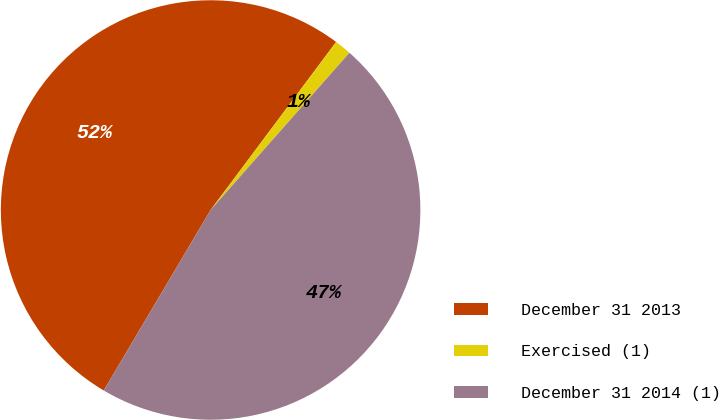Convert chart to OTSL. <chart><loc_0><loc_0><loc_500><loc_500><pie_chart><fcel>December 31 2013<fcel>Exercised (1)<fcel>December 31 2014 (1)<nl><fcel>51.7%<fcel>1.3%<fcel>47.0%<nl></chart> 